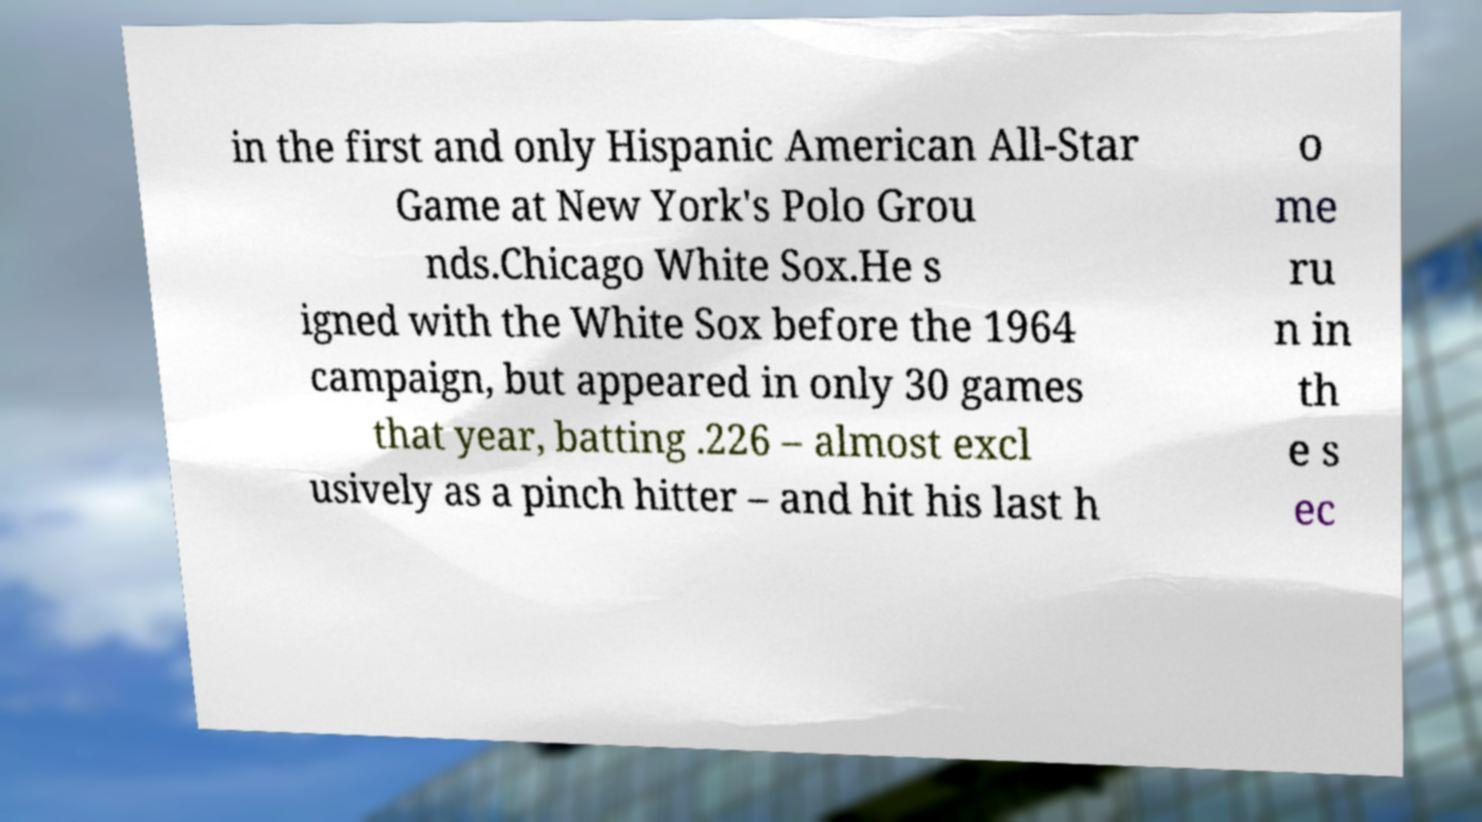Can you accurately transcribe the text from the provided image for me? in the first and only Hispanic American All-Star Game at New York's Polo Grou nds.Chicago White Sox.He s igned with the White Sox before the 1964 campaign, but appeared in only 30 games that year, batting .226 – almost excl usively as a pinch hitter – and hit his last h o me ru n in th e s ec 